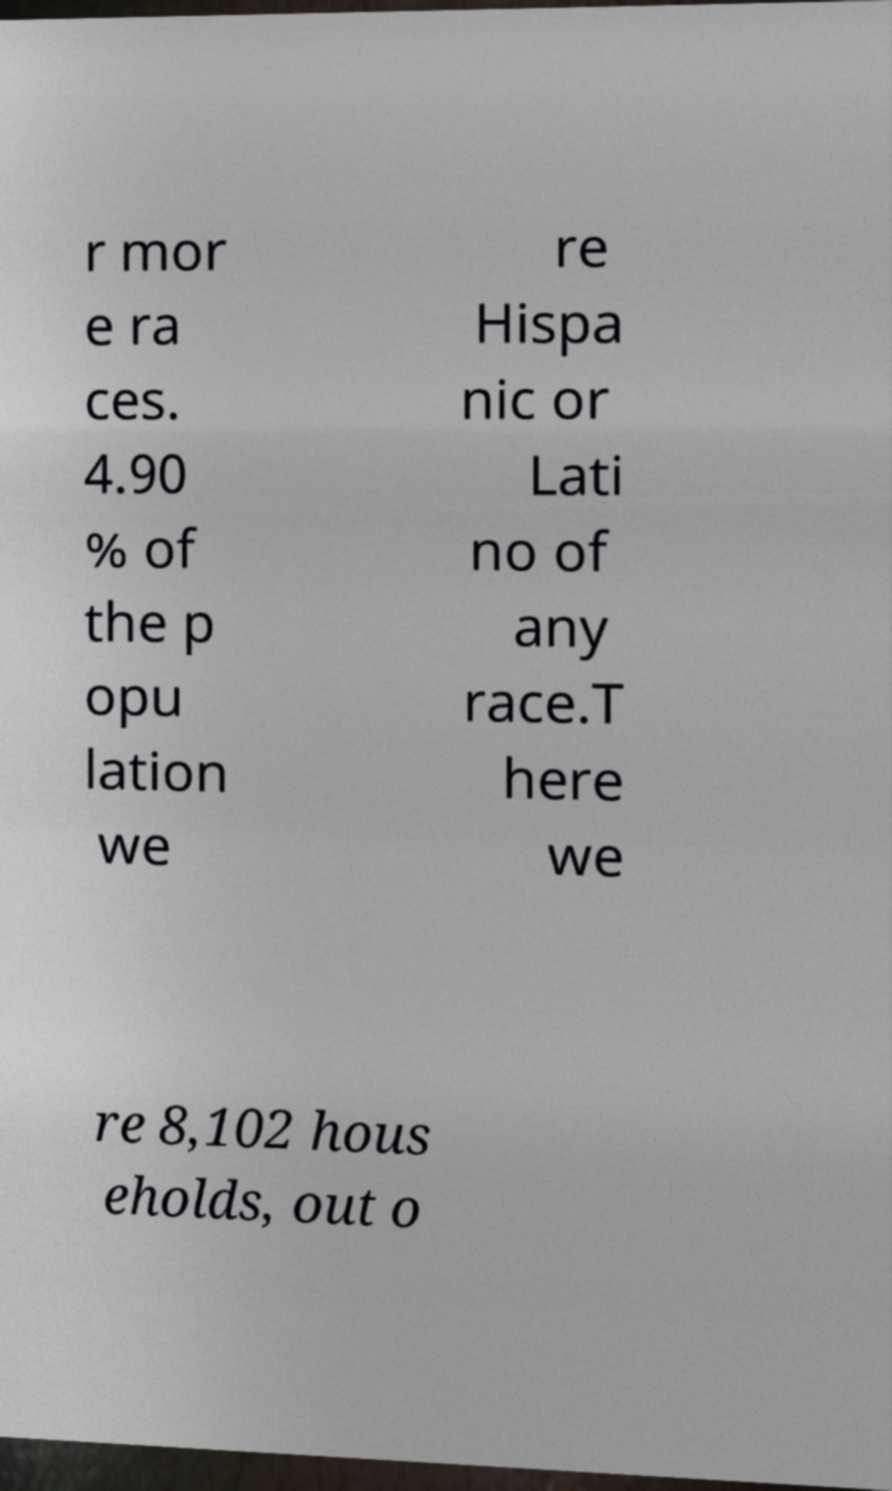What messages or text are displayed in this image? I need them in a readable, typed format. r mor e ra ces. 4.90 % of the p opu lation we re Hispa nic or Lati no of any race.T here we re 8,102 hous eholds, out o 